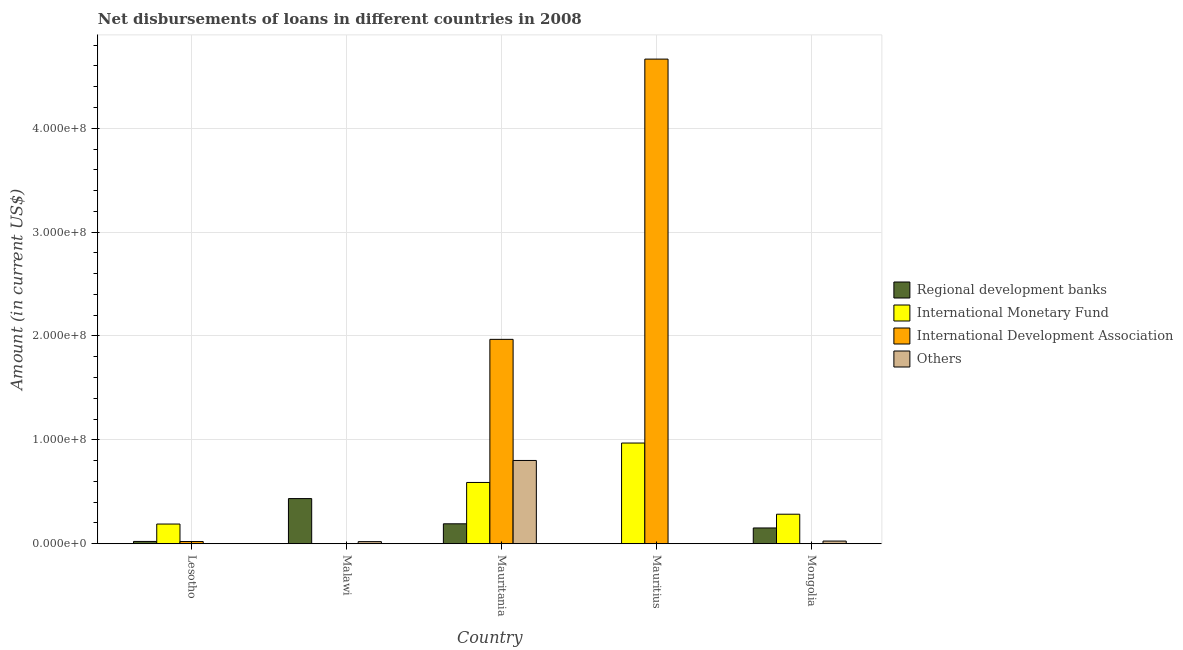How many different coloured bars are there?
Your response must be concise. 4. How many bars are there on the 4th tick from the left?
Your response must be concise. 2. How many bars are there on the 2nd tick from the right?
Your response must be concise. 2. What is the label of the 1st group of bars from the left?
Make the answer very short. Lesotho. In how many cases, is the number of bars for a given country not equal to the number of legend labels?
Your answer should be very brief. 4. What is the amount of loan disimbursed by other organisations in Lesotho?
Ensure brevity in your answer.  0. Across all countries, what is the maximum amount of loan disimbursed by international monetary fund?
Offer a very short reply. 9.70e+07. In which country was the amount of loan disimbursed by other organisations maximum?
Your response must be concise. Mauritania. What is the total amount of loan disimbursed by other organisations in the graph?
Provide a short and direct response. 8.48e+07. What is the difference between the amount of loan disimbursed by regional development banks in Malawi and that in Mauritania?
Offer a very short reply. 2.43e+07. What is the difference between the amount of loan disimbursed by international monetary fund in Lesotho and the amount of loan disimbursed by international development association in Mauritania?
Your answer should be compact. -1.78e+08. What is the average amount of loan disimbursed by international development association per country?
Make the answer very short. 1.33e+08. What is the difference between the amount of loan disimbursed by regional development banks and amount of loan disimbursed by other organisations in Malawi?
Make the answer very short. 4.14e+07. What is the ratio of the amount of loan disimbursed by international development association in Lesotho to that in Mauritania?
Your response must be concise. 0.01. What is the difference between the highest and the second highest amount of loan disimbursed by international development association?
Your answer should be compact. 2.70e+08. What is the difference between the highest and the lowest amount of loan disimbursed by regional development banks?
Your response must be concise. 4.35e+07. Is the sum of the amount of loan disimbursed by regional development banks in Lesotho and Malawi greater than the maximum amount of loan disimbursed by other organisations across all countries?
Provide a short and direct response. No. How many bars are there?
Provide a succinct answer. 14. Are all the bars in the graph horizontal?
Keep it short and to the point. No. How many countries are there in the graph?
Offer a very short reply. 5. What is the difference between two consecutive major ticks on the Y-axis?
Ensure brevity in your answer.  1.00e+08. Are the values on the major ticks of Y-axis written in scientific E-notation?
Your response must be concise. Yes. Does the graph contain any zero values?
Your response must be concise. Yes. Where does the legend appear in the graph?
Give a very brief answer. Center right. How many legend labels are there?
Keep it short and to the point. 4. What is the title of the graph?
Keep it short and to the point. Net disbursements of loans in different countries in 2008. Does "Tertiary education" appear as one of the legend labels in the graph?
Give a very brief answer. No. What is the Amount (in current US$) of Regional development banks in Lesotho?
Your answer should be very brief. 2.23e+06. What is the Amount (in current US$) of International Monetary Fund in Lesotho?
Your answer should be very brief. 1.90e+07. What is the Amount (in current US$) of International Development Association in Lesotho?
Provide a short and direct response. 2.13e+06. What is the Amount (in current US$) in Others in Lesotho?
Ensure brevity in your answer.  0. What is the Amount (in current US$) of Regional development banks in Malawi?
Keep it short and to the point. 4.35e+07. What is the Amount (in current US$) in International Monetary Fund in Malawi?
Your answer should be compact. 0. What is the Amount (in current US$) in International Development Association in Malawi?
Your answer should be compact. 0. What is the Amount (in current US$) of Others in Malawi?
Make the answer very short. 2.04e+06. What is the Amount (in current US$) in Regional development banks in Mauritania?
Offer a terse response. 1.92e+07. What is the Amount (in current US$) of International Monetary Fund in Mauritania?
Make the answer very short. 5.90e+07. What is the Amount (in current US$) of International Development Association in Mauritania?
Your answer should be compact. 1.97e+08. What is the Amount (in current US$) of Others in Mauritania?
Offer a terse response. 8.02e+07. What is the Amount (in current US$) of Regional development banks in Mauritius?
Make the answer very short. 0. What is the Amount (in current US$) of International Monetary Fund in Mauritius?
Provide a short and direct response. 9.70e+07. What is the Amount (in current US$) in International Development Association in Mauritius?
Ensure brevity in your answer.  4.67e+08. What is the Amount (in current US$) of Others in Mauritius?
Your answer should be compact. 0. What is the Amount (in current US$) of Regional development banks in Mongolia?
Your answer should be very brief. 1.52e+07. What is the Amount (in current US$) in International Monetary Fund in Mongolia?
Give a very brief answer. 2.84e+07. What is the Amount (in current US$) of Others in Mongolia?
Ensure brevity in your answer.  2.58e+06. Across all countries, what is the maximum Amount (in current US$) of Regional development banks?
Your answer should be compact. 4.35e+07. Across all countries, what is the maximum Amount (in current US$) in International Monetary Fund?
Offer a very short reply. 9.70e+07. Across all countries, what is the maximum Amount (in current US$) in International Development Association?
Provide a short and direct response. 4.67e+08. Across all countries, what is the maximum Amount (in current US$) in Others?
Your answer should be very brief. 8.02e+07. Across all countries, what is the minimum Amount (in current US$) in Regional development banks?
Offer a terse response. 0. What is the total Amount (in current US$) in Regional development banks in the graph?
Provide a short and direct response. 8.01e+07. What is the total Amount (in current US$) in International Monetary Fund in the graph?
Provide a short and direct response. 2.03e+08. What is the total Amount (in current US$) of International Development Association in the graph?
Your answer should be very brief. 6.65e+08. What is the total Amount (in current US$) in Others in the graph?
Your answer should be very brief. 8.48e+07. What is the difference between the Amount (in current US$) of Regional development banks in Lesotho and that in Malawi?
Ensure brevity in your answer.  -4.12e+07. What is the difference between the Amount (in current US$) of Regional development banks in Lesotho and that in Mauritania?
Provide a succinct answer. -1.70e+07. What is the difference between the Amount (in current US$) of International Monetary Fund in Lesotho and that in Mauritania?
Offer a terse response. -4.00e+07. What is the difference between the Amount (in current US$) in International Development Association in Lesotho and that in Mauritania?
Make the answer very short. -1.95e+08. What is the difference between the Amount (in current US$) of International Monetary Fund in Lesotho and that in Mauritius?
Provide a succinct answer. -7.80e+07. What is the difference between the Amount (in current US$) of International Development Association in Lesotho and that in Mauritius?
Ensure brevity in your answer.  -4.64e+08. What is the difference between the Amount (in current US$) in Regional development banks in Lesotho and that in Mongolia?
Your response must be concise. -1.30e+07. What is the difference between the Amount (in current US$) in International Monetary Fund in Lesotho and that in Mongolia?
Your response must be concise. -9.47e+06. What is the difference between the Amount (in current US$) in Regional development banks in Malawi and that in Mauritania?
Your answer should be very brief. 2.43e+07. What is the difference between the Amount (in current US$) of Others in Malawi and that in Mauritania?
Provide a succinct answer. -7.81e+07. What is the difference between the Amount (in current US$) in Regional development banks in Malawi and that in Mongolia?
Offer a very short reply. 2.83e+07. What is the difference between the Amount (in current US$) of Others in Malawi and that in Mongolia?
Keep it short and to the point. -5.44e+05. What is the difference between the Amount (in current US$) in International Monetary Fund in Mauritania and that in Mauritius?
Your response must be concise. -3.80e+07. What is the difference between the Amount (in current US$) in International Development Association in Mauritania and that in Mauritius?
Provide a short and direct response. -2.70e+08. What is the difference between the Amount (in current US$) of Regional development banks in Mauritania and that in Mongolia?
Keep it short and to the point. 4.00e+06. What is the difference between the Amount (in current US$) in International Monetary Fund in Mauritania and that in Mongolia?
Offer a very short reply. 3.06e+07. What is the difference between the Amount (in current US$) in Others in Mauritania and that in Mongolia?
Your response must be concise. 7.76e+07. What is the difference between the Amount (in current US$) in International Monetary Fund in Mauritius and that in Mongolia?
Offer a very short reply. 6.85e+07. What is the difference between the Amount (in current US$) of Regional development banks in Lesotho and the Amount (in current US$) of Others in Malawi?
Provide a short and direct response. 1.98e+05. What is the difference between the Amount (in current US$) of International Monetary Fund in Lesotho and the Amount (in current US$) of Others in Malawi?
Your answer should be very brief. 1.69e+07. What is the difference between the Amount (in current US$) in International Development Association in Lesotho and the Amount (in current US$) in Others in Malawi?
Give a very brief answer. 9.30e+04. What is the difference between the Amount (in current US$) of Regional development banks in Lesotho and the Amount (in current US$) of International Monetary Fund in Mauritania?
Your answer should be compact. -5.68e+07. What is the difference between the Amount (in current US$) in Regional development banks in Lesotho and the Amount (in current US$) in International Development Association in Mauritania?
Ensure brevity in your answer.  -1.95e+08. What is the difference between the Amount (in current US$) of Regional development banks in Lesotho and the Amount (in current US$) of Others in Mauritania?
Provide a short and direct response. -7.79e+07. What is the difference between the Amount (in current US$) of International Monetary Fund in Lesotho and the Amount (in current US$) of International Development Association in Mauritania?
Offer a terse response. -1.78e+08. What is the difference between the Amount (in current US$) of International Monetary Fund in Lesotho and the Amount (in current US$) of Others in Mauritania?
Give a very brief answer. -6.12e+07. What is the difference between the Amount (in current US$) in International Development Association in Lesotho and the Amount (in current US$) in Others in Mauritania?
Provide a short and direct response. -7.81e+07. What is the difference between the Amount (in current US$) of Regional development banks in Lesotho and the Amount (in current US$) of International Monetary Fund in Mauritius?
Offer a very short reply. -9.47e+07. What is the difference between the Amount (in current US$) in Regional development banks in Lesotho and the Amount (in current US$) in International Development Association in Mauritius?
Provide a succinct answer. -4.64e+08. What is the difference between the Amount (in current US$) in International Monetary Fund in Lesotho and the Amount (in current US$) in International Development Association in Mauritius?
Make the answer very short. -4.48e+08. What is the difference between the Amount (in current US$) in Regional development banks in Lesotho and the Amount (in current US$) in International Monetary Fund in Mongolia?
Ensure brevity in your answer.  -2.62e+07. What is the difference between the Amount (in current US$) in Regional development banks in Lesotho and the Amount (in current US$) in Others in Mongolia?
Keep it short and to the point. -3.46e+05. What is the difference between the Amount (in current US$) in International Monetary Fund in Lesotho and the Amount (in current US$) in Others in Mongolia?
Make the answer very short. 1.64e+07. What is the difference between the Amount (in current US$) in International Development Association in Lesotho and the Amount (in current US$) in Others in Mongolia?
Ensure brevity in your answer.  -4.51e+05. What is the difference between the Amount (in current US$) of Regional development banks in Malawi and the Amount (in current US$) of International Monetary Fund in Mauritania?
Provide a short and direct response. -1.55e+07. What is the difference between the Amount (in current US$) in Regional development banks in Malawi and the Amount (in current US$) in International Development Association in Mauritania?
Give a very brief answer. -1.53e+08. What is the difference between the Amount (in current US$) in Regional development banks in Malawi and the Amount (in current US$) in Others in Mauritania?
Ensure brevity in your answer.  -3.67e+07. What is the difference between the Amount (in current US$) of Regional development banks in Malawi and the Amount (in current US$) of International Monetary Fund in Mauritius?
Provide a short and direct response. -5.35e+07. What is the difference between the Amount (in current US$) in Regional development banks in Malawi and the Amount (in current US$) in International Development Association in Mauritius?
Offer a terse response. -4.23e+08. What is the difference between the Amount (in current US$) of Regional development banks in Malawi and the Amount (in current US$) of International Monetary Fund in Mongolia?
Give a very brief answer. 1.50e+07. What is the difference between the Amount (in current US$) of Regional development banks in Malawi and the Amount (in current US$) of Others in Mongolia?
Your answer should be very brief. 4.09e+07. What is the difference between the Amount (in current US$) in Regional development banks in Mauritania and the Amount (in current US$) in International Monetary Fund in Mauritius?
Offer a very short reply. -7.78e+07. What is the difference between the Amount (in current US$) in Regional development banks in Mauritania and the Amount (in current US$) in International Development Association in Mauritius?
Offer a very short reply. -4.47e+08. What is the difference between the Amount (in current US$) in International Monetary Fund in Mauritania and the Amount (in current US$) in International Development Association in Mauritius?
Keep it short and to the point. -4.08e+08. What is the difference between the Amount (in current US$) in Regional development banks in Mauritania and the Amount (in current US$) in International Monetary Fund in Mongolia?
Keep it short and to the point. -9.25e+06. What is the difference between the Amount (in current US$) in Regional development banks in Mauritania and the Amount (in current US$) in Others in Mongolia?
Keep it short and to the point. 1.66e+07. What is the difference between the Amount (in current US$) in International Monetary Fund in Mauritania and the Amount (in current US$) in Others in Mongolia?
Give a very brief answer. 5.64e+07. What is the difference between the Amount (in current US$) of International Development Association in Mauritania and the Amount (in current US$) of Others in Mongolia?
Offer a very short reply. 1.94e+08. What is the difference between the Amount (in current US$) in International Monetary Fund in Mauritius and the Amount (in current US$) in Others in Mongolia?
Offer a terse response. 9.44e+07. What is the difference between the Amount (in current US$) in International Development Association in Mauritius and the Amount (in current US$) in Others in Mongolia?
Offer a very short reply. 4.64e+08. What is the average Amount (in current US$) of Regional development banks per country?
Your answer should be compact. 1.60e+07. What is the average Amount (in current US$) in International Monetary Fund per country?
Your response must be concise. 4.07e+07. What is the average Amount (in current US$) in International Development Association per country?
Your answer should be very brief. 1.33e+08. What is the average Amount (in current US$) of Others per country?
Provide a short and direct response. 1.70e+07. What is the difference between the Amount (in current US$) in Regional development banks and Amount (in current US$) in International Monetary Fund in Lesotho?
Give a very brief answer. -1.67e+07. What is the difference between the Amount (in current US$) in Regional development banks and Amount (in current US$) in International Development Association in Lesotho?
Provide a succinct answer. 1.05e+05. What is the difference between the Amount (in current US$) of International Monetary Fund and Amount (in current US$) of International Development Association in Lesotho?
Give a very brief answer. 1.68e+07. What is the difference between the Amount (in current US$) in Regional development banks and Amount (in current US$) in Others in Malawi?
Your answer should be very brief. 4.14e+07. What is the difference between the Amount (in current US$) of Regional development banks and Amount (in current US$) of International Monetary Fund in Mauritania?
Offer a terse response. -3.98e+07. What is the difference between the Amount (in current US$) in Regional development banks and Amount (in current US$) in International Development Association in Mauritania?
Your answer should be very brief. -1.78e+08. What is the difference between the Amount (in current US$) of Regional development banks and Amount (in current US$) of Others in Mauritania?
Your answer should be compact. -6.10e+07. What is the difference between the Amount (in current US$) in International Monetary Fund and Amount (in current US$) in International Development Association in Mauritania?
Offer a terse response. -1.38e+08. What is the difference between the Amount (in current US$) in International Monetary Fund and Amount (in current US$) in Others in Mauritania?
Keep it short and to the point. -2.12e+07. What is the difference between the Amount (in current US$) in International Development Association and Amount (in current US$) in Others in Mauritania?
Make the answer very short. 1.17e+08. What is the difference between the Amount (in current US$) of International Monetary Fund and Amount (in current US$) of International Development Association in Mauritius?
Your answer should be compact. -3.70e+08. What is the difference between the Amount (in current US$) of Regional development banks and Amount (in current US$) of International Monetary Fund in Mongolia?
Keep it short and to the point. -1.32e+07. What is the difference between the Amount (in current US$) in Regional development banks and Amount (in current US$) in Others in Mongolia?
Provide a succinct answer. 1.26e+07. What is the difference between the Amount (in current US$) of International Monetary Fund and Amount (in current US$) of Others in Mongolia?
Keep it short and to the point. 2.59e+07. What is the ratio of the Amount (in current US$) in Regional development banks in Lesotho to that in Malawi?
Make the answer very short. 0.05. What is the ratio of the Amount (in current US$) in Regional development banks in Lesotho to that in Mauritania?
Give a very brief answer. 0.12. What is the ratio of the Amount (in current US$) of International Monetary Fund in Lesotho to that in Mauritania?
Keep it short and to the point. 0.32. What is the ratio of the Amount (in current US$) in International Development Association in Lesotho to that in Mauritania?
Ensure brevity in your answer.  0.01. What is the ratio of the Amount (in current US$) of International Monetary Fund in Lesotho to that in Mauritius?
Give a very brief answer. 0.2. What is the ratio of the Amount (in current US$) of International Development Association in Lesotho to that in Mauritius?
Provide a short and direct response. 0. What is the ratio of the Amount (in current US$) in Regional development banks in Lesotho to that in Mongolia?
Offer a very short reply. 0.15. What is the ratio of the Amount (in current US$) of International Monetary Fund in Lesotho to that in Mongolia?
Provide a succinct answer. 0.67. What is the ratio of the Amount (in current US$) of Regional development banks in Malawi to that in Mauritania?
Offer a very short reply. 2.27. What is the ratio of the Amount (in current US$) in Others in Malawi to that in Mauritania?
Make the answer very short. 0.03. What is the ratio of the Amount (in current US$) of Regional development banks in Malawi to that in Mongolia?
Your answer should be very brief. 2.86. What is the ratio of the Amount (in current US$) in Others in Malawi to that in Mongolia?
Provide a succinct answer. 0.79. What is the ratio of the Amount (in current US$) in International Monetary Fund in Mauritania to that in Mauritius?
Offer a very short reply. 0.61. What is the ratio of the Amount (in current US$) of International Development Association in Mauritania to that in Mauritius?
Your response must be concise. 0.42. What is the ratio of the Amount (in current US$) in Regional development banks in Mauritania to that in Mongolia?
Offer a very short reply. 1.26. What is the ratio of the Amount (in current US$) in International Monetary Fund in Mauritania to that in Mongolia?
Provide a succinct answer. 2.07. What is the ratio of the Amount (in current US$) in Others in Mauritania to that in Mongolia?
Ensure brevity in your answer.  31.09. What is the ratio of the Amount (in current US$) in International Monetary Fund in Mauritius to that in Mongolia?
Ensure brevity in your answer.  3.41. What is the difference between the highest and the second highest Amount (in current US$) of Regional development banks?
Your answer should be very brief. 2.43e+07. What is the difference between the highest and the second highest Amount (in current US$) of International Monetary Fund?
Keep it short and to the point. 3.80e+07. What is the difference between the highest and the second highest Amount (in current US$) of International Development Association?
Your answer should be compact. 2.70e+08. What is the difference between the highest and the second highest Amount (in current US$) of Others?
Offer a very short reply. 7.76e+07. What is the difference between the highest and the lowest Amount (in current US$) in Regional development banks?
Ensure brevity in your answer.  4.35e+07. What is the difference between the highest and the lowest Amount (in current US$) of International Monetary Fund?
Your response must be concise. 9.70e+07. What is the difference between the highest and the lowest Amount (in current US$) of International Development Association?
Provide a succinct answer. 4.67e+08. What is the difference between the highest and the lowest Amount (in current US$) of Others?
Your response must be concise. 8.02e+07. 